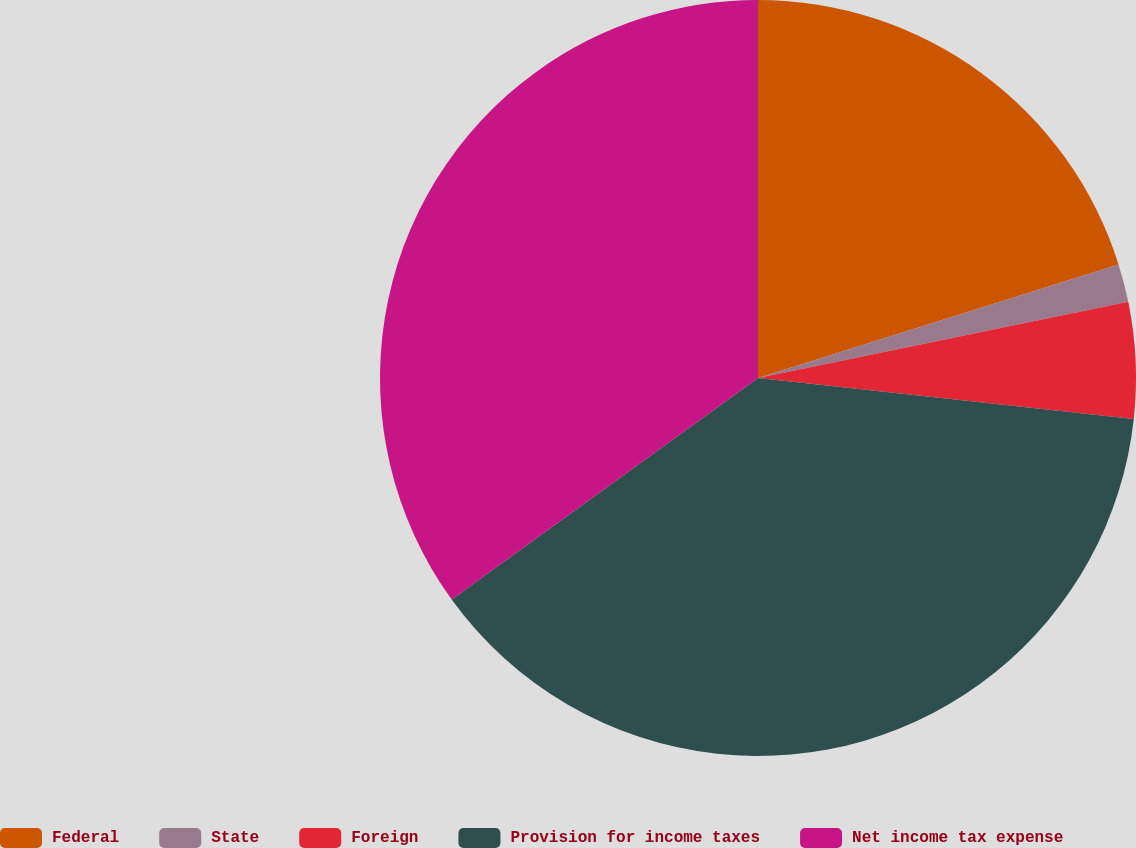<chart> <loc_0><loc_0><loc_500><loc_500><pie_chart><fcel>Federal<fcel>State<fcel>Foreign<fcel>Provision for income taxes<fcel>Net income tax expense<nl><fcel>20.14%<fcel>1.63%<fcel>4.96%<fcel>38.3%<fcel>34.96%<nl></chart> 